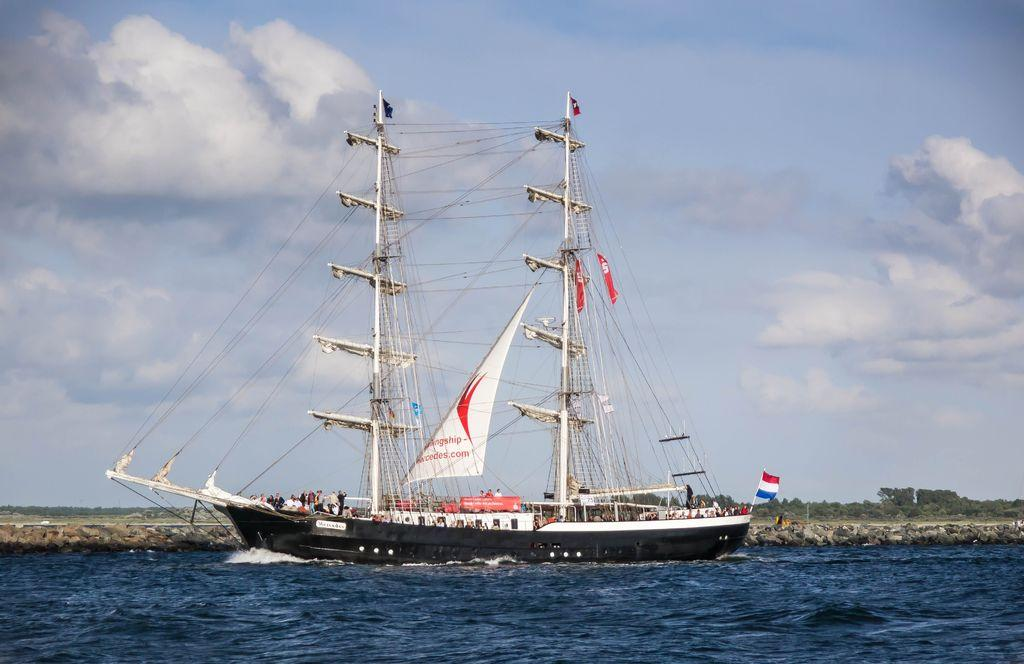What is the main subject of the image? The main subject of the image is a ship. Where is the ship located? The ship is on the water. What can be seen in the image besides the ship? There is a flag, poles, trees, people, and the sky visible in the image. What is the condition of the sky in the image? The sky is visible in the background of the image, and there are clouds present. What type of friction can be seen between the ship and the water in the image? There is no specific type of friction visible between the ship and the water in the image. Can you tell me how many planes are flying in the sky in the image? There are no planes visible in the sky in the image. 